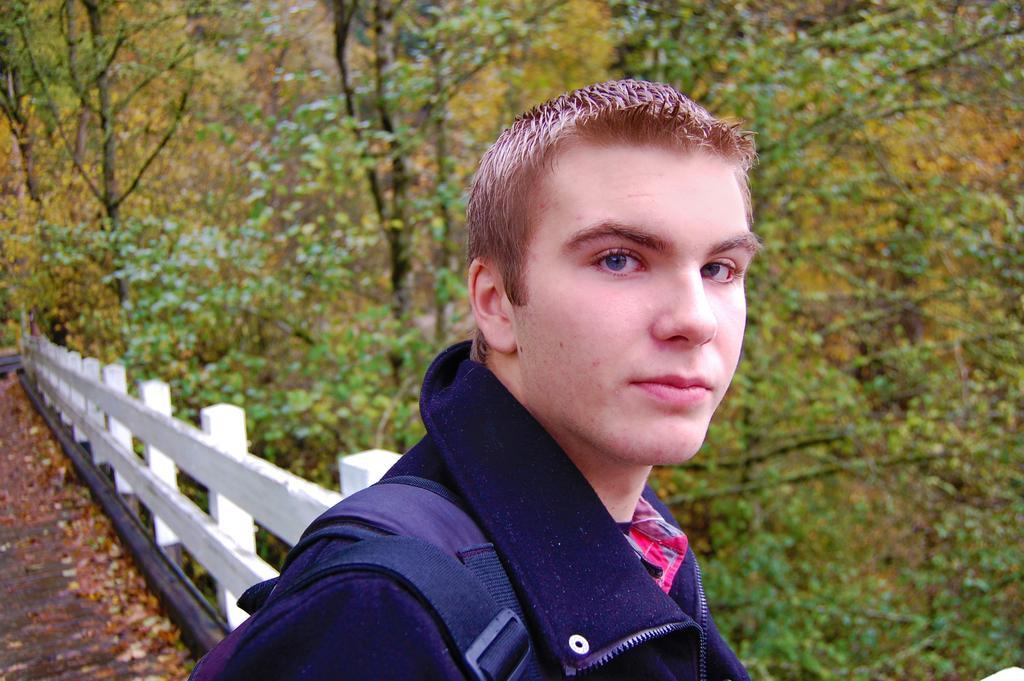Could you give a brief overview of what you see in this image? In this image we can see a person and in the background there is a fence and few trees. 